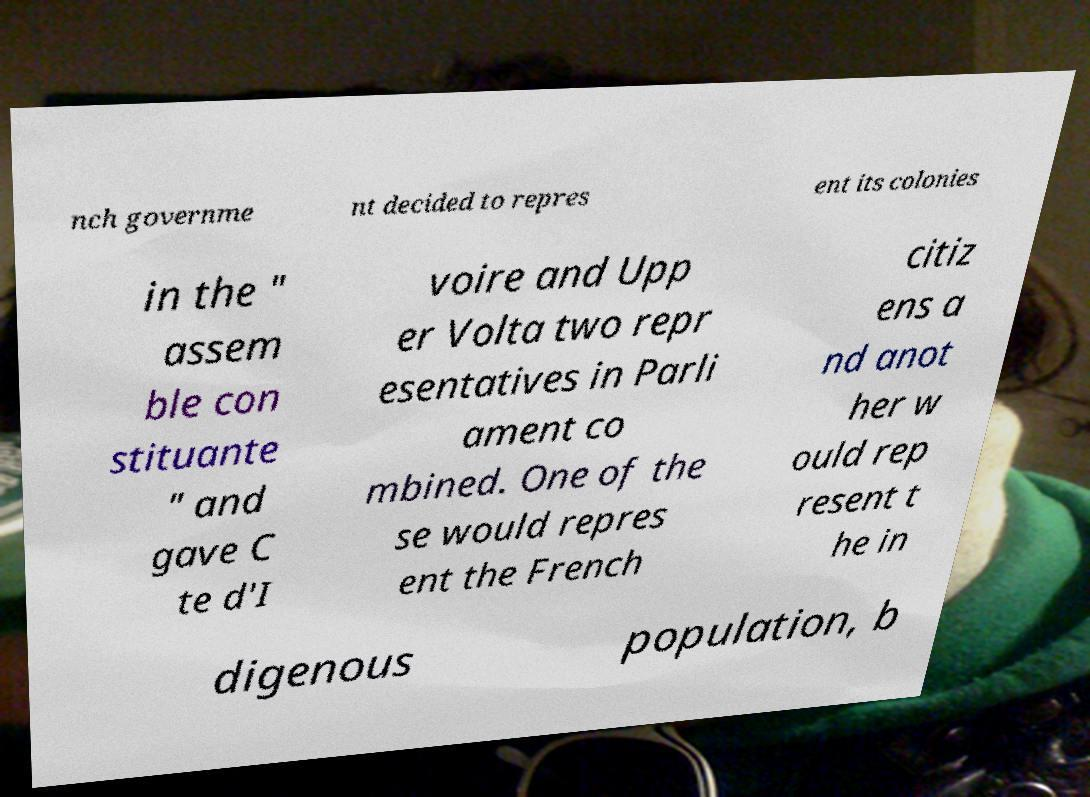I need the written content from this picture converted into text. Can you do that? nch governme nt decided to repres ent its colonies in the " assem ble con stituante " and gave C te d'I voire and Upp er Volta two repr esentatives in Parli ament co mbined. One of the se would repres ent the French citiz ens a nd anot her w ould rep resent t he in digenous population, b 